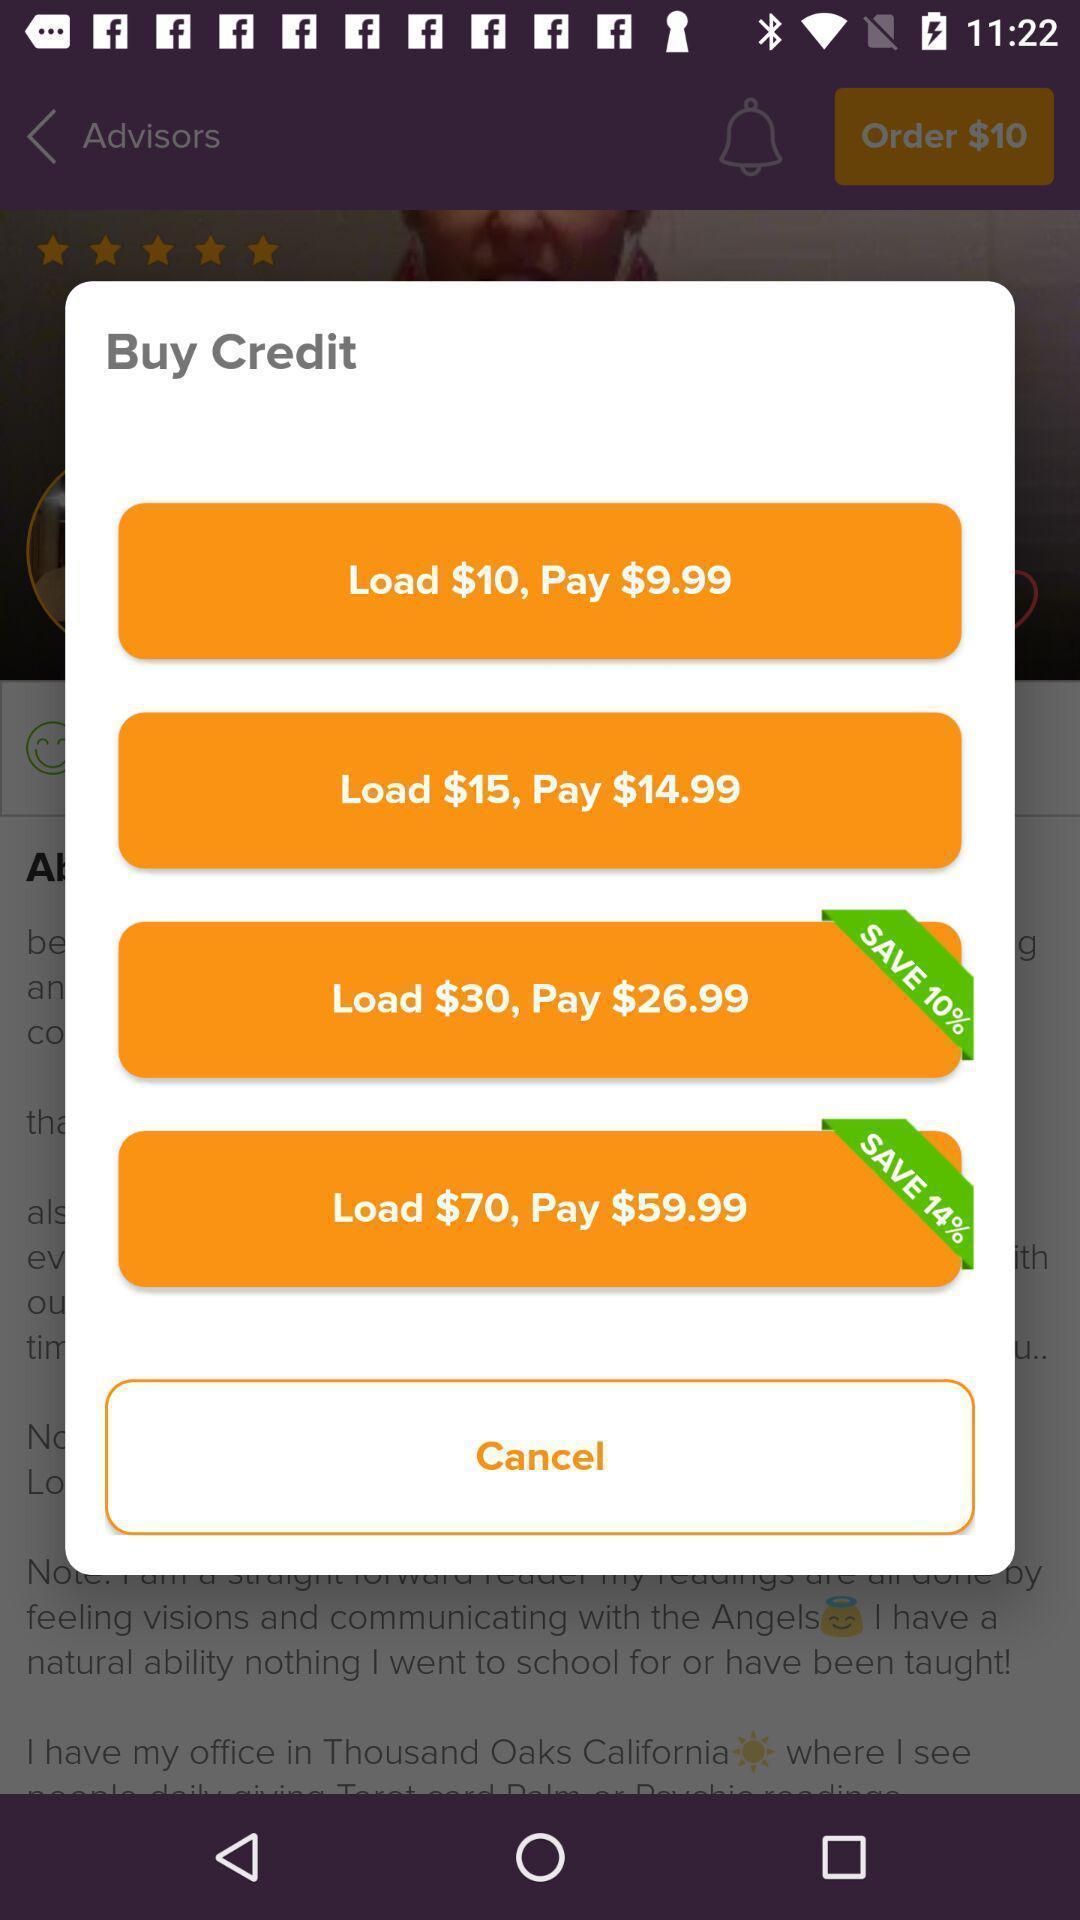What is the overall content of this screenshot? Screen shows to buy credits. 